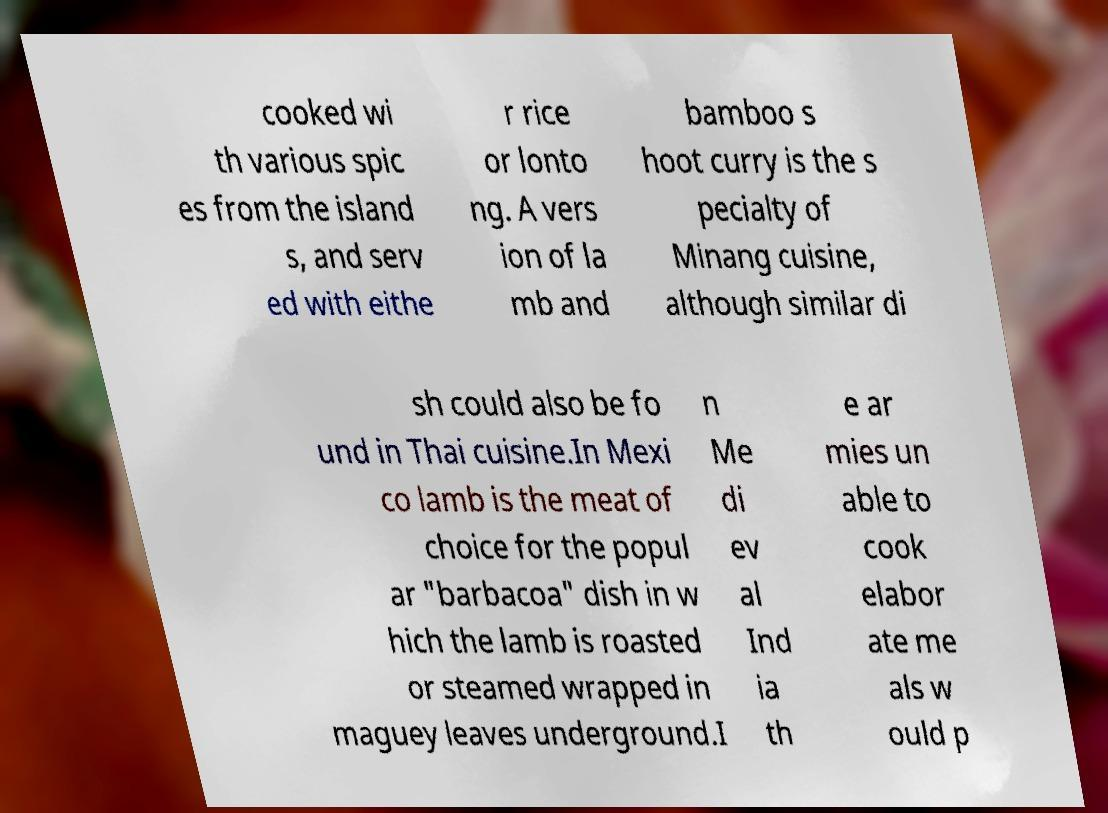Please identify and transcribe the text found in this image. cooked wi th various spic es from the island s, and serv ed with eithe r rice or lonto ng. A vers ion of la mb and bamboo s hoot curry is the s pecialty of Minang cuisine, although similar di sh could also be fo und in Thai cuisine.In Mexi co lamb is the meat of choice for the popul ar "barbacoa" dish in w hich the lamb is roasted or steamed wrapped in maguey leaves underground.I n Me di ev al Ind ia th e ar mies un able to cook elabor ate me als w ould p 